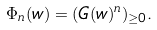Convert formula to latex. <formula><loc_0><loc_0><loc_500><loc_500>\Phi _ { n } ( w ) = ( G ( w ) ^ { n } ) _ { \geq 0 } .</formula> 